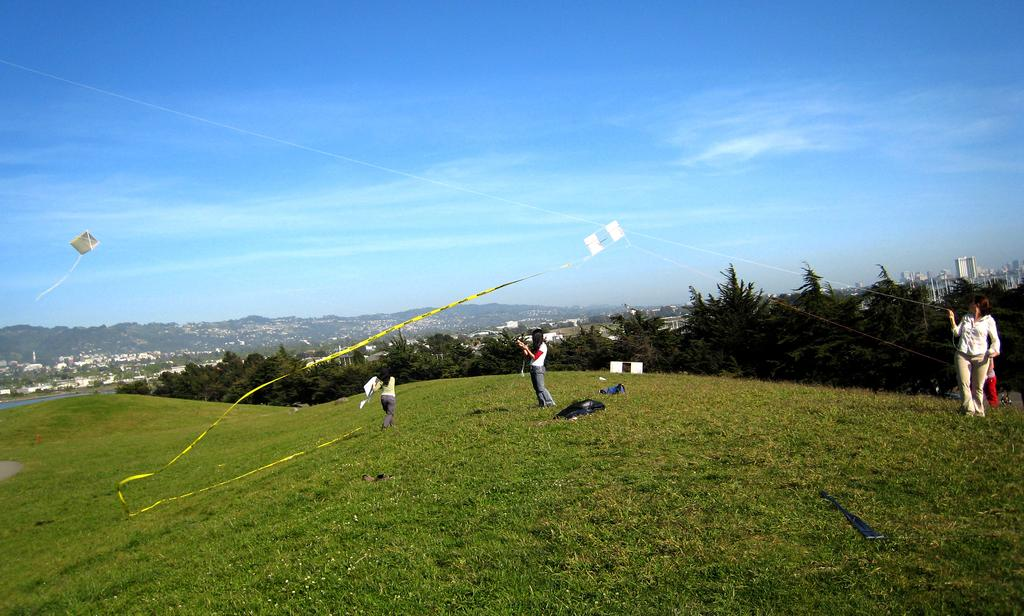What type of landscape is depicted in the image? There is a grassland in the image. What activity are the people engaged in on the grassland? People are flying kites on the grassland. What can be seen in the background of the image? There are trees and a building in the background of the image. What color is the sky in the image? The sky is blue in the image. How many chairs are placed on the seashore in the image? There is no seashore present in the image, and therefore no chairs can be found there. 